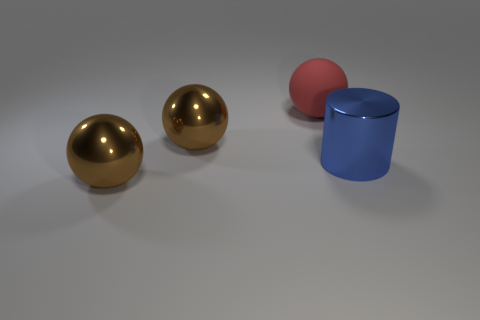What is the shape of the large blue thing?
Your answer should be compact. Cylinder. There is a brown object that is behind the ball in front of the blue cylinder; how big is it?
Give a very brief answer. Large. Are there the same number of big matte objects on the right side of the big red thing and large metal objects that are on the right side of the big cylinder?
Offer a very short reply. Yes. There is a ball that is left of the red matte thing and behind the blue cylinder; what material is it made of?
Provide a succinct answer. Metal. Does the red thing have the same size as the shiny thing right of the large red rubber object?
Your answer should be compact. Yes. What number of other things are the same color as the big matte thing?
Your answer should be compact. 0. Is the number of big blue things on the right side of the metallic cylinder greater than the number of large cyan cylinders?
Your response must be concise. No. There is a large thing that is to the left of the brown metal object behind the big metallic thing that is to the right of the red matte ball; what is its color?
Offer a terse response. Brown. Is the material of the large red object the same as the blue thing?
Your answer should be compact. No. Is there a gray matte thing of the same size as the blue metal cylinder?
Ensure brevity in your answer.  No. 